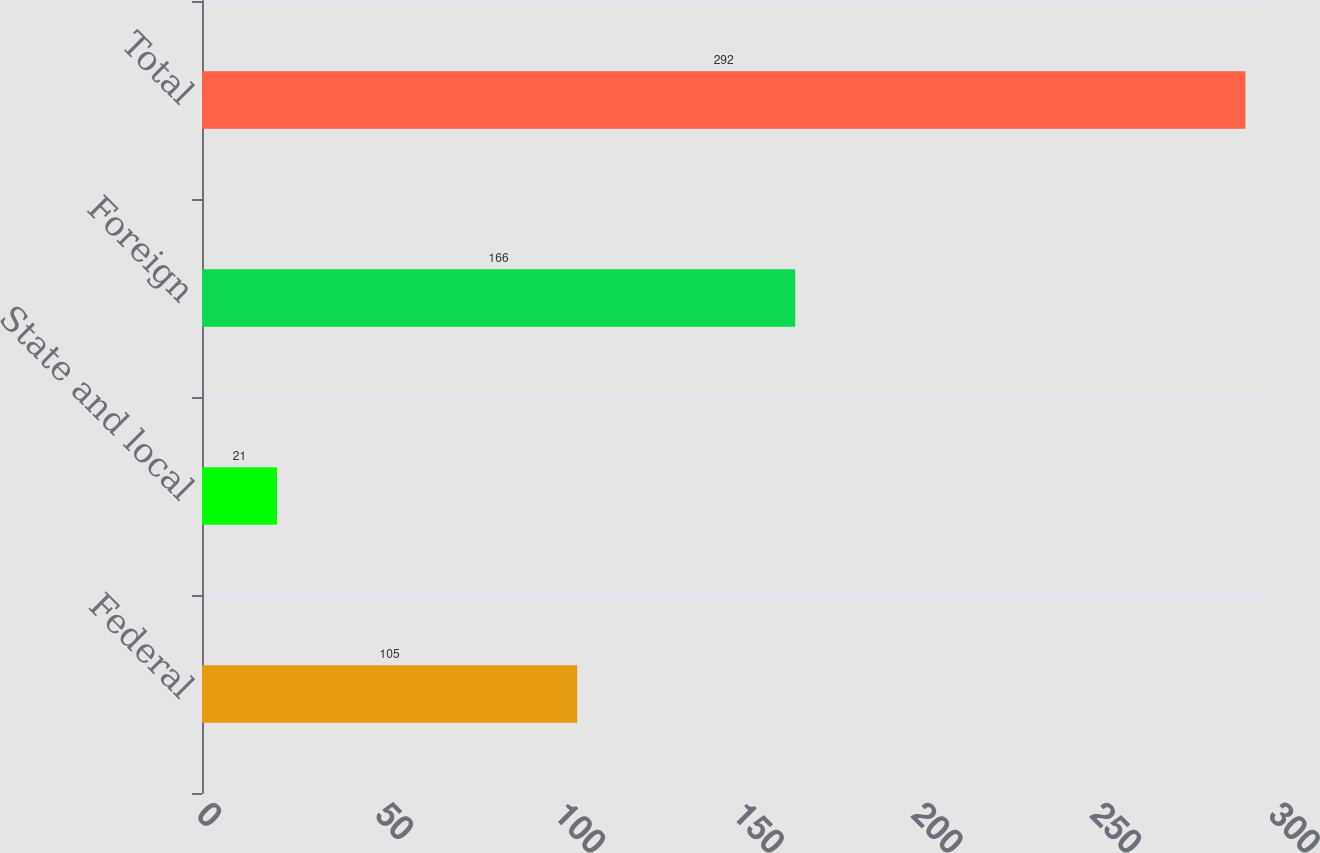Convert chart. <chart><loc_0><loc_0><loc_500><loc_500><bar_chart><fcel>Federal<fcel>State and local<fcel>Foreign<fcel>Total<nl><fcel>105<fcel>21<fcel>166<fcel>292<nl></chart> 